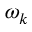<formula> <loc_0><loc_0><loc_500><loc_500>\omega _ { k }</formula> 